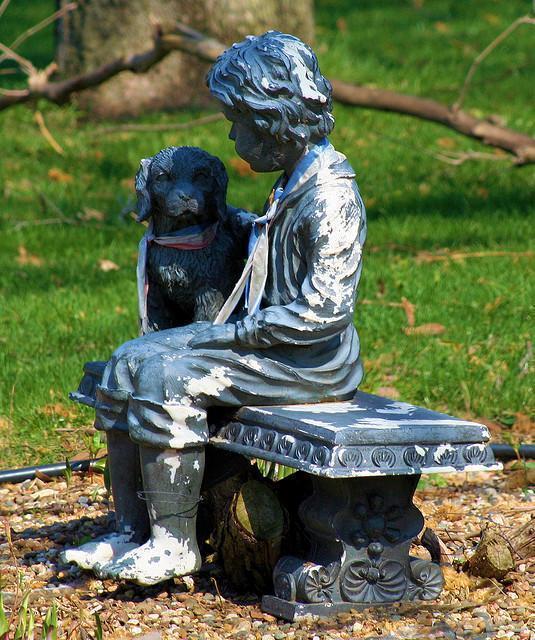Why is this statue partially white?
Choose the correct response, then elucidate: 'Answer: answer
Rationale: rationale.'
Options: Age, style, bird droppings, water discoloration. Answer: bird droppings.
Rationale: The statue is partially white because it is covered with bird droppings. 